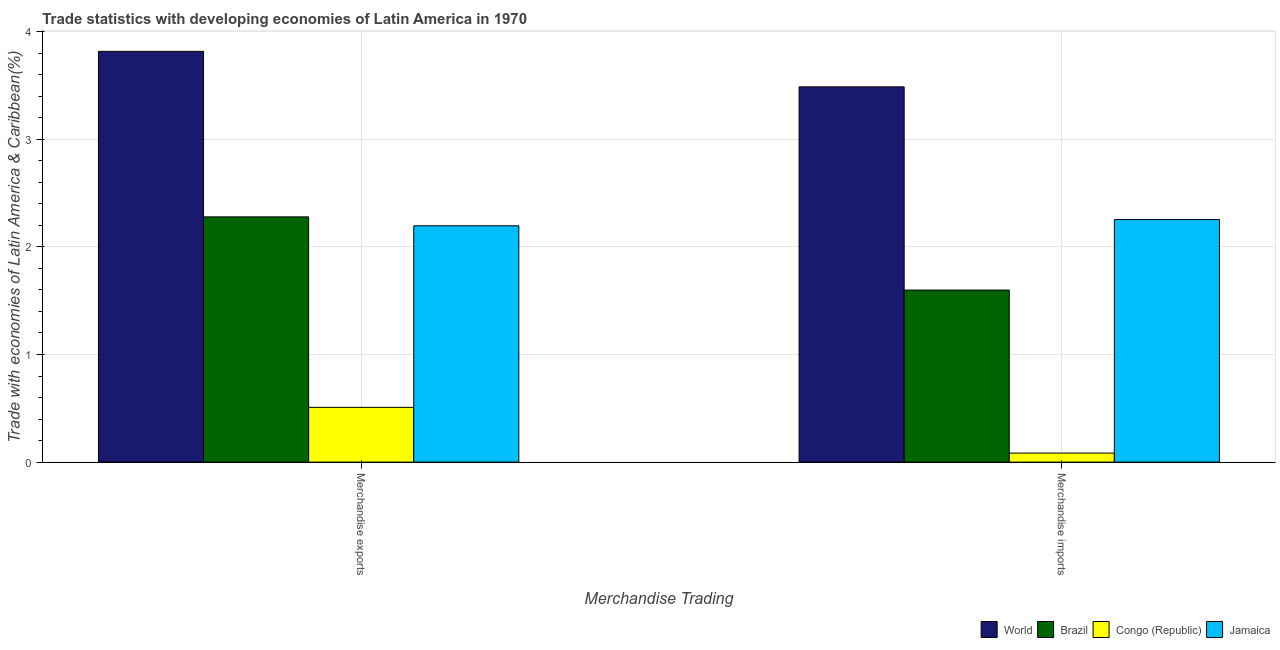How many different coloured bars are there?
Ensure brevity in your answer.  4. What is the label of the 2nd group of bars from the left?
Your response must be concise. Merchandise imports. What is the merchandise exports in World?
Keep it short and to the point. 3.82. Across all countries, what is the maximum merchandise exports?
Your answer should be very brief. 3.82. Across all countries, what is the minimum merchandise exports?
Provide a short and direct response. 0.51. In which country was the merchandise exports minimum?
Provide a short and direct response. Congo (Republic). What is the total merchandise imports in the graph?
Your answer should be very brief. 7.42. What is the difference between the merchandise exports in Jamaica and that in Brazil?
Keep it short and to the point. -0.08. What is the difference between the merchandise imports in Jamaica and the merchandise exports in Congo (Republic)?
Your answer should be very brief. 1.74. What is the average merchandise imports per country?
Keep it short and to the point. 1.86. What is the difference between the merchandise exports and merchandise imports in Brazil?
Provide a short and direct response. 0.68. What is the ratio of the merchandise imports in Jamaica to that in Brazil?
Offer a terse response. 1.41. In how many countries, is the merchandise imports greater than the average merchandise imports taken over all countries?
Provide a short and direct response. 2. How many bars are there?
Your response must be concise. 8. How many countries are there in the graph?
Your answer should be compact. 4. Does the graph contain any zero values?
Provide a succinct answer. No. What is the title of the graph?
Give a very brief answer. Trade statistics with developing economies of Latin America in 1970. What is the label or title of the X-axis?
Give a very brief answer. Merchandise Trading. What is the label or title of the Y-axis?
Your answer should be very brief. Trade with economies of Latin America & Caribbean(%). What is the Trade with economies of Latin America & Caribbean(%) in World in Merchandise exports?
Make the answer very short. 3.82. What is the Trade with economies of Latin America & Caribbean(%) in Brazil in Merchandise exports?
Offer a terse response. 2.28. What is the Trade with economies of Latin America & Caribbean(%) in Congo (Republic) in Merchandise exports?
Your answer should be compact. 0.51. What is the Trade with economies of Latin America & Caribbean(%) in Jamaica in Merchandise exports?
Make the answer very short. 2.2. What is the Trade with economies of Latin America & Caribbean(%) of World in Merchandise imports?
Provide a short and direct response. 3.49. What is the Trade with economies of Latin America & Caribbean(%) in Brazil in Merchandise imports?
Your answer should be very brief. 1.6. What is the Trade with economies of Latin America & Caribbean(%) in Congo (Republic) in Merchandise imports?
Give a very brief answer. 0.08. What is the Trade with economies of Latin America & Caribbean(%) of Jamaica in Merchandise imports?
Make the answer very short. 2.25. Across all Merchandise Trading, what is the maximum Trade with economies of Latin America & Caribbean(%) in World?
Offer a terse response. 3.82. Across all Merchandise Trading, what is the maximum Trade with economies of Latin America & Caribbean(%) in Brazil?
Give a very brief answer. 2.28. Across all Merchandise Trading, what is the maximum Trade with economies of Latin America & Caribbean(%) of Congo (Republic)?
Your response must be concise. 0.51. Across all Merchandise Trading, what is the maximum Trade with economies of Latin America & Caribbean(%) of Jamaica?
Ensure brevity in your answer.  2.25. Across all Merchandise Trading, what is the minimum Trade with economies of Latin America & Caribbean(%) in World?
Offer a very short reply. 3.49. Across all Merchandise Trading, what is the minimum Trade with economies of Latin America & Caribbean(%) of Brazil?
Ensure brevity in your answer.  1.6. Across all Merchandise Trading, what is the minimum Trade with economies of Latin America & Caribbean(%) in Congo (Republic)?
Make the answer very short. 0.08. Across all Merchandise Trading, what is the minimum Trade with economies of Latin America & Caribbean(%) in Jamaica?
Your answer should be compact. 2.2. What is the total Trade with economies of Latin America & Caribbean(%) in World in the graph?
Your answer should be very brief. 7.3. What is the total Trade with economies of Latin America & Caribbean(%) in Brazil in the graph?
Give a very brief answer. 3.88. What is the total Trade with economies of Latin America & Caribbean(%) in Congo (Republic) in the graph?
Provide a succinct answer. 0.59. What is the total Trade with economies of Latin America & Caribbean(%) in Jamaica in the graph?
Your response must be concise. 4.45. What is the difference between the Trade with economies of Latin America & Caribbean(%) in World in Merchandise exports and that in Merchandise imports?
Keep it short and to the point. 0.33. What is the difference between the Trade with economies of Latin America & Caribbean(%) in Brazil in Merchandise exports and that in Merchandise imports?
Make the answer very short. 0.68. What is the difference between the Trade with economies of Latin America & Caribbean(%) of Congo (Republic) in Merchandise exports and that in Merchandise imports?
Keep it short and to the point. 0.42. What is the difference between the Trade with economies of Latin America & Caribbean(%) in Jamaica in Merchandise exports and that in Merchandise imports?
Your answer should be compact. -0.06. What is the difference between the Trade with economies of Latin America & Caribbean(%) in World in Merchandise exports and the Trade with economies of Latin America & Caribbean(%) in Brazil in Merchandise imports?
Offer a very short reply. 2.22. What is the difference between the Trade with economies of Latin America & Caribbean(%) of World in Merchandise exports and the Trade with economies of Latin America & Caribbean(%) of Congo (Republic) in Merchandise imports?
Offer a terse response. 3.73. What is the difference between the Trade with economies of Latin America & Caribbean(%) of World in Merchandise exports and the Trade with economies of Latin America & Caribbean(%) of Jamaica in Merchandise imports?
Your answer should be very brief. 1.56. What is the difference between the Trade with economies of Latin America & Caribbean(%) in Brazil in Merchandise exports and the Trade with economies of Latin America & Caribbean(%) in Congo (Republic) in Merchandise imports?
Ensure brevity in your answer.  2.19. What is the difference between the Trade with economies of Latin America & Caribbean(%) of Brazil in Merchandise exports and the Trade with economies of Latin America & Caribbean(%) of Jamaica in Merchandise imports?
Give a very brief answer. 0.03. What is the difference between the Trade with economies of Latin America & Caribbean(%) in Congo (Republic) in Merchandise exports and the Trade with economies of Latin America & Caribbean(%) in Jamaica in Merchandise imports?
Your answer should be compact. -1.74. What is the average Trade with economies of Latin America & Caribbean(%) of World per Merchandise Trading?
Give a very brief answer. 3.65. What is the average Trade with economies of Latin America & Caribbean(%) of Brazil per Merchandise Trading?
Your answer should be very brief. 1.94. What is the average Trade with economies of Latin America & Caribbean(%) of Congo (Republic) per Merchandise Trading?
Keep it short and to the point. 0.3. What is the average Trade with economies of Latin America & Caribbean(%) of Jamaica per Merchandise Trading?
Your answer should be compact. 2.22. What is the difference between the Trade with economies of Latin America & Caribbean(%) of World and Trade with economies of Latin America & Caribbean(%) of Brazil in Merchandise exports?
Provide a short and direct response. 1.54. What is the difference between the Trade with economies of Latin America & Caribbean(%) in World and Trade with economies of Latin America & Caribbean(%) in Congo (Republic) in Merchandise exports?
Offer a terse response. 3.31. What is the difference between the Trade with economies of Latin America & Caribbean(%) of World and Trade with economies of Latin America & Caribbean(%) of Jamaica in Merchandise exports?
Your response must be concise. 1.62. What is the difference between the Trade with economies of Latin America & Caribbean(%) of Brazil and Trade with economies of Latin America & Caribbean(%) of Congo (Republic) in Merchandise exports?
Offer a terse response. 1.77. What is the difference between the Trade with economies of Latin America & Caribbean(%) of Brazil and Trade with economies of Latin America & Caribbean(%) of Jamaica in Merchandise exports?
Provide a short and direct response. 0.08. What is the difference between the Trade with economies of Latin America & Caribbean(%) of Congo (Republic) and Trade with economies of Latin America & Caribbean(%) of Jamaica in Merchandise exports?
Your response must be concise. -1.69. What is the difference between the Trade with economies of Latin America & Caribbean(%) in World and Trade with economies of Latin America & Caribbean(%) in Brazil in Merchandise imports?
Offer a terse response. 1.89. What is the difference between the Trade with economies of Latin America & Caribbean(%) of World and Trade with economies of Latin America & Caribbean(%) of Congo (Republic) in Merchandise imports?
Provide a short and direct response. 3.4. What is the difference between the Trade with economies of Latin America & Caribbean(%) in World and Trade with economies of Latin America & Caribbean(%) in Jamaica in Merchandise imports?
Give a very brief answer. 1.23. What is the difference between the Trade with economies of Latin America & Caribbean(%) in Brazil and Trade with economies of Latin America & Caribbean(%) in Congo (Republic) in Merchandise imports?
Offer a terse response. 1.51. What is the difference between the Trade with economies of Latin America & Caribbean(%) of Brazil and Trade with economies of Latin America & Caribbean(%) of Jamaica in Merchandise imports?
Offer a very short reply. -0.66. What is the difference between the Trade with economies of Latin America & Caribbean(%) in Congo (Republic) and Trade with economies of Latin America & Caribbean(%) in Jamaica in Merchandise imports?
Offer a terse response. -2.17. What is the ratio of the Trade with economies of Latin America & Caribbean(%) of World in Merchandise exports to that in Merchandise imports?
Provide a short and direct response. 1.09. What is the ratio of the Trade with economies of Latin America & Caribbean(%) of Brazil in Merchandise exports to that in Merchandise imports?
Your answer should be very brief. 1.43. What is the ratio of the Trade with economies of Latin America & Caribbean(%) in Congo (Republic) in Merchandise exports to that in Merchandise imports?
Offer a terse response. 6.06. What is the ratio of the Trade with economies of Latin America & Caribbean(%) in Jamaica in Merchandise exports to that in Merchandise imports?
Offer a very short reply. 0.97. What is the difference between the highest and the second highest Trade with economies of Latin America & Caribbean(%) of World?
Keep it short and to the point. 0.33. What is the difference between the highest and the second highest Trade with economies of Latin America & Caribbean(%) of Brazil?
Offer a terse response. 0.68. What is the difference between the highest and the second highest Trade with economies of Latin America & Caribbean(%) of Congo (Republic)?
Your answer should be very brief. 0.42. What is the difference between the highest and the second highest Trade with economies of Latin America & Caribbean(%) of Jamaica?
Give a very brief answer. 0.06. What is the difference between the highest and the lowest Trade with economies of Latin America & Caribbean(%) in World?
Provide a succinct answer. 0.33. What is the difference between the highest and the lowest Trade with economies of Latin America & Caribbean(%) in Brazil?
Offer a terse response. 0.68. What is the difference between the highest and the lowest Trade with economies of Latin America & Caribbean(%) in Congo (Republic)?
Provide a succinct answer. 0.42. What is the difference between the highest and the lowest Trade with economies of Latin America & Caribbean(%) in Jamaica?
Offer a very short reply. 0.06. 